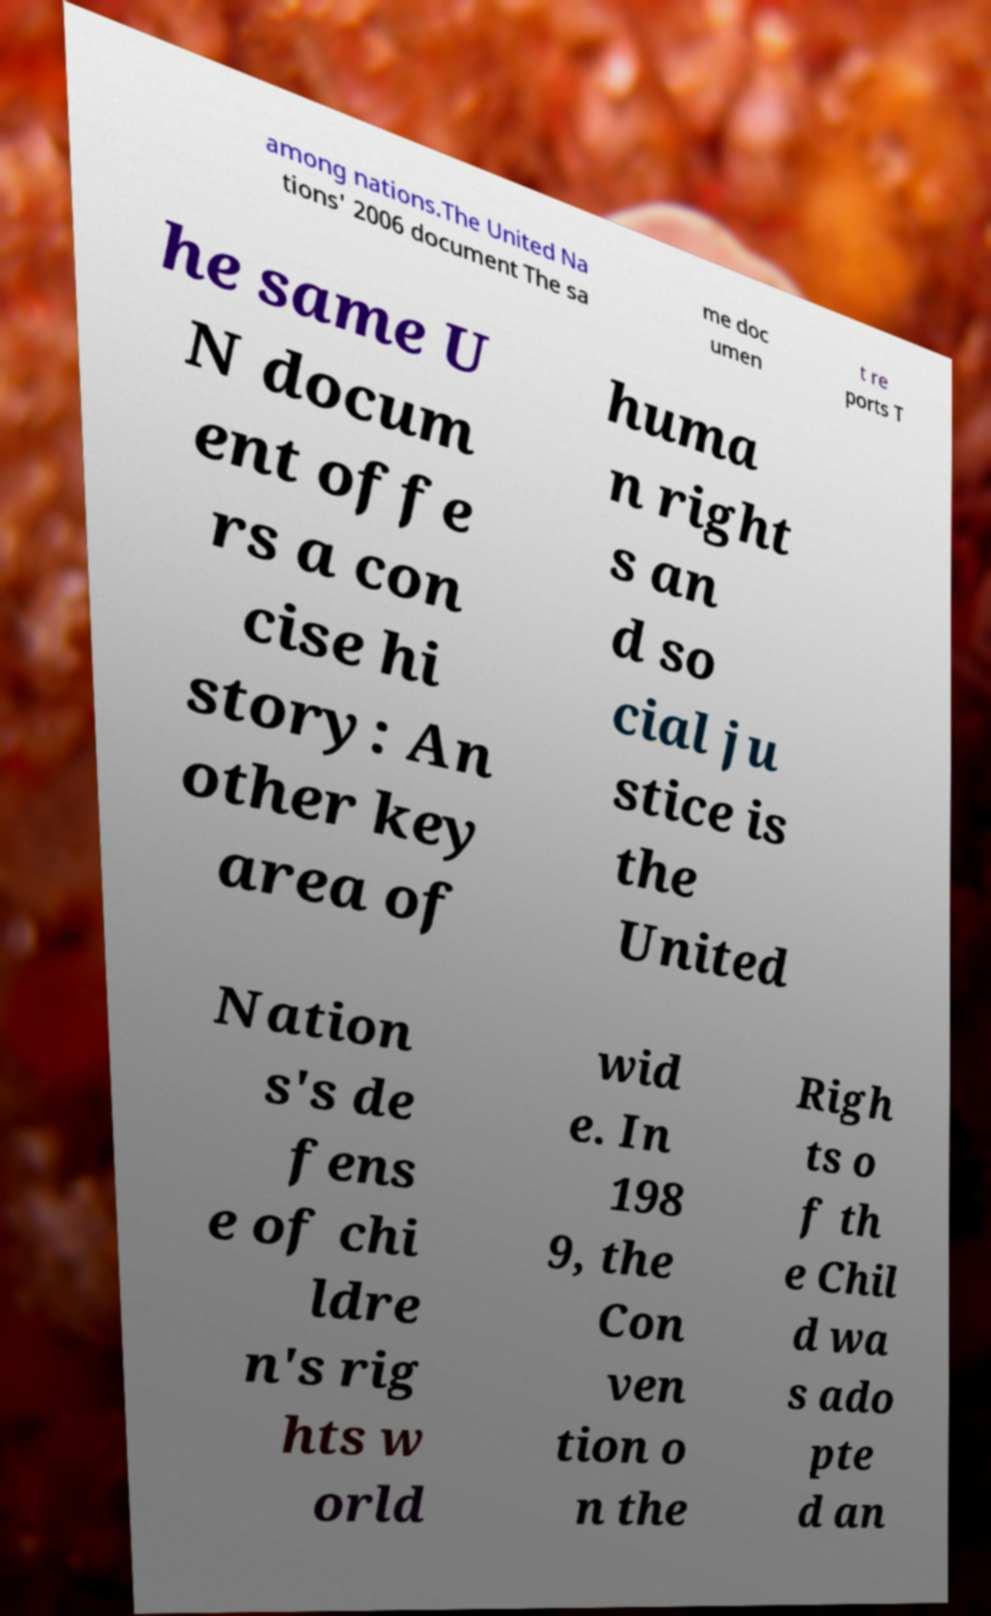There's text embedded in this image that I need extracted. Can you transcribe it verbatim? among nations.The United Na tions' 2006 document The sa me doc umen t re ports T he same U N docum ent offe rs a con cise hi story: An other key area of huma n right s an d so cial ju stice is the United Nation s's de fens e of chi ldre n's rig hts w orld wid e. In 198 9, the Con ven tion o n the Righ ts o f th e Chil d wa s ado pte d an 